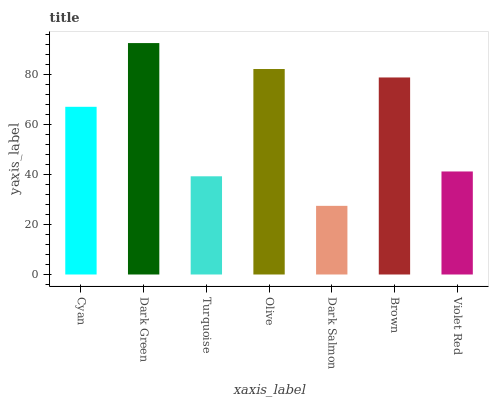Is Turquoise the minimum?
Answer yes or no. No. Is Turquoise the maximum?
Answer yes or no. No. Is Dark Green greater than Turquoise?
Answer yes or no. Yes. Is Turquoise less than Dark Green?
Answer yes or no. Yes. Is Turquoise greater than Dark Green?
Answer yes or no. No. Is Dark Green less than Turquoise?
Answer yes or no. No. Is Cyan the high median?
Answer yes or no. Yes. Is Cyan the low median?
Answer yes or no. Yes. Is Dark Green the high median?
Answer yes or no. No. Is Dark Salmon the low median?
Answer yes or no. No. 